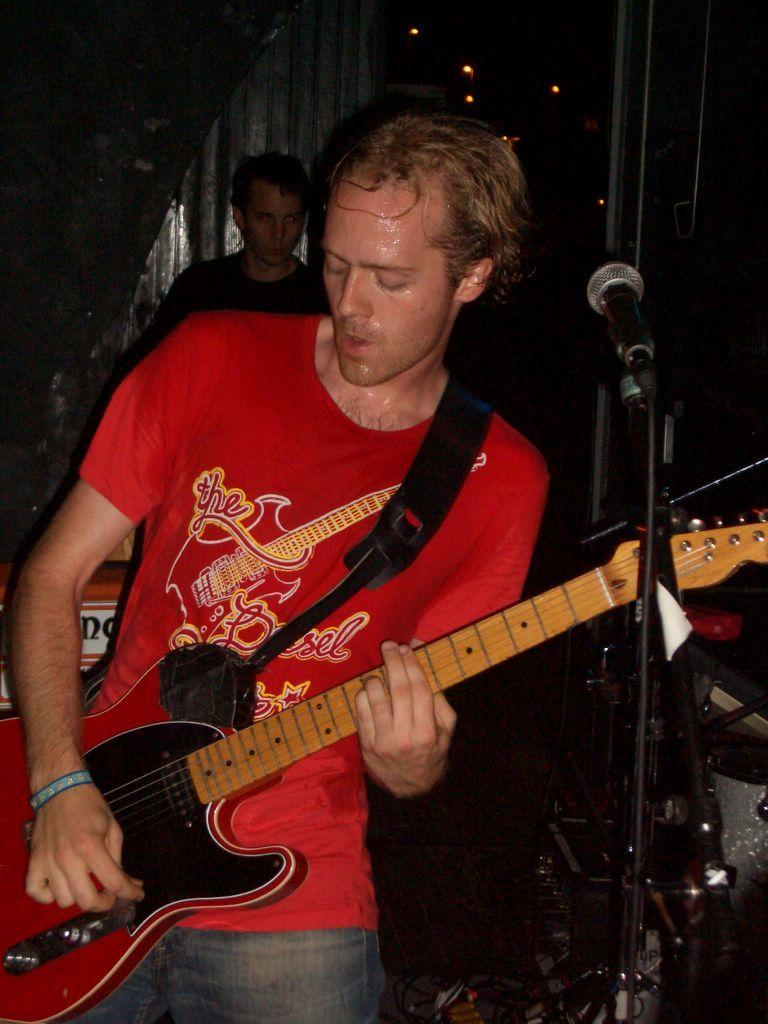What is the main subject of the image? There is a person in the image. What is the person doing in the image? The person is standing in the image. What object is the person holding in their hand? The person is holding a guitar in their hand. Where is the nest located in the image? There is no nest present in the image. What season is depicted in the image? The provided facts do not mention any season, so it cannot be determined from the image. 